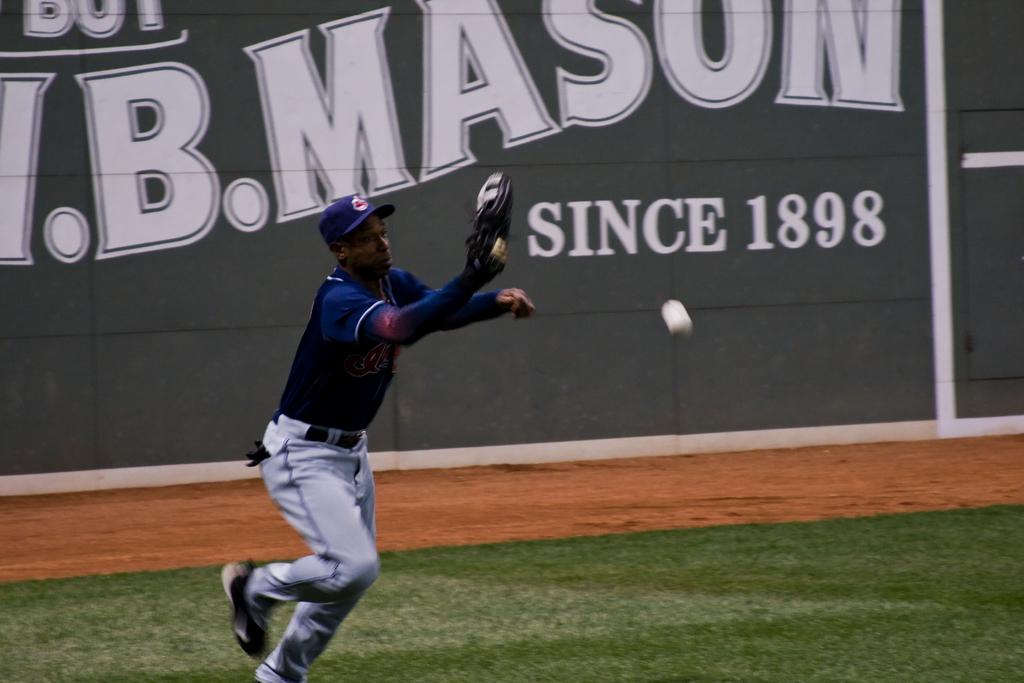What is the year on the banner?
Provide a succinct answer. 1898. 